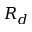<formula> <loc_0><loc_0><loc_500><loc_500>R _ { d }</formula> 